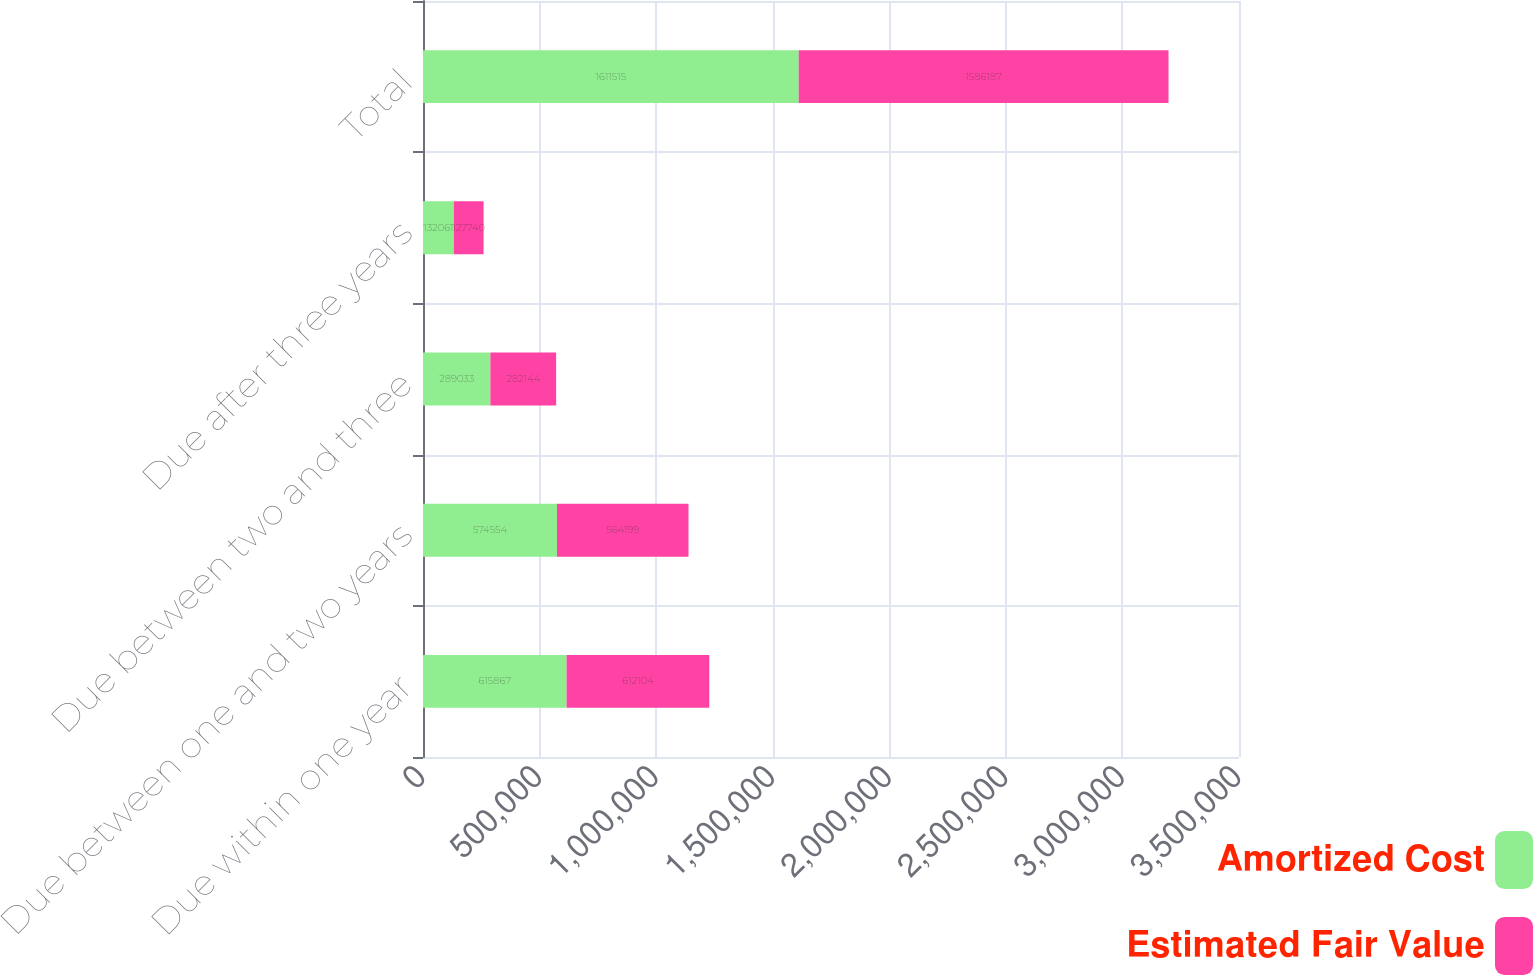Convert chart. <chart><loc_0><loc_0><loc_500><loc_500><stacked_bar_chart><ecel><fcel>Due within one year<fcel>Due between one and two years<fcel>Due between two and three<fcel>Due after three years<fcel>Total<nl><fcel>Amortized Cost<fcel>615867<fcel>574554<fcel>289033<fcel>132061<fcel>1.61152e+06<nl><fcel>Estimated Fair Value<fcel>612104<fcel>564199<fcel>282144<fcel>127740<fcel>1.58619e+06<nl></chart> 